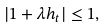<formula> <loc_0><loc_0><loc_500><loc_500>| 1 + \lambda h _ { t } | \leq 1 ,</formula> 